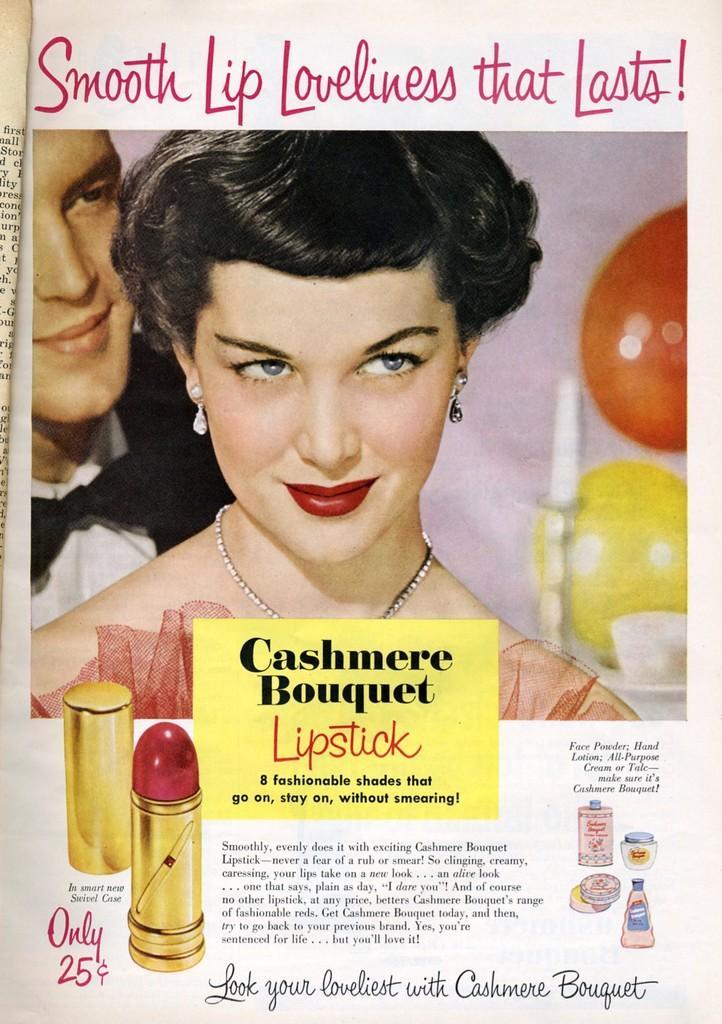In one or two sentences, can you explain what this image depicts? The picture is a poster. At the bottom there are lipstick, text, number and other objects. In the center of the picture there is a woman and a man. At the top there is text. On the left there is a newspaper. On the right there are some objects in red and yellow color. 